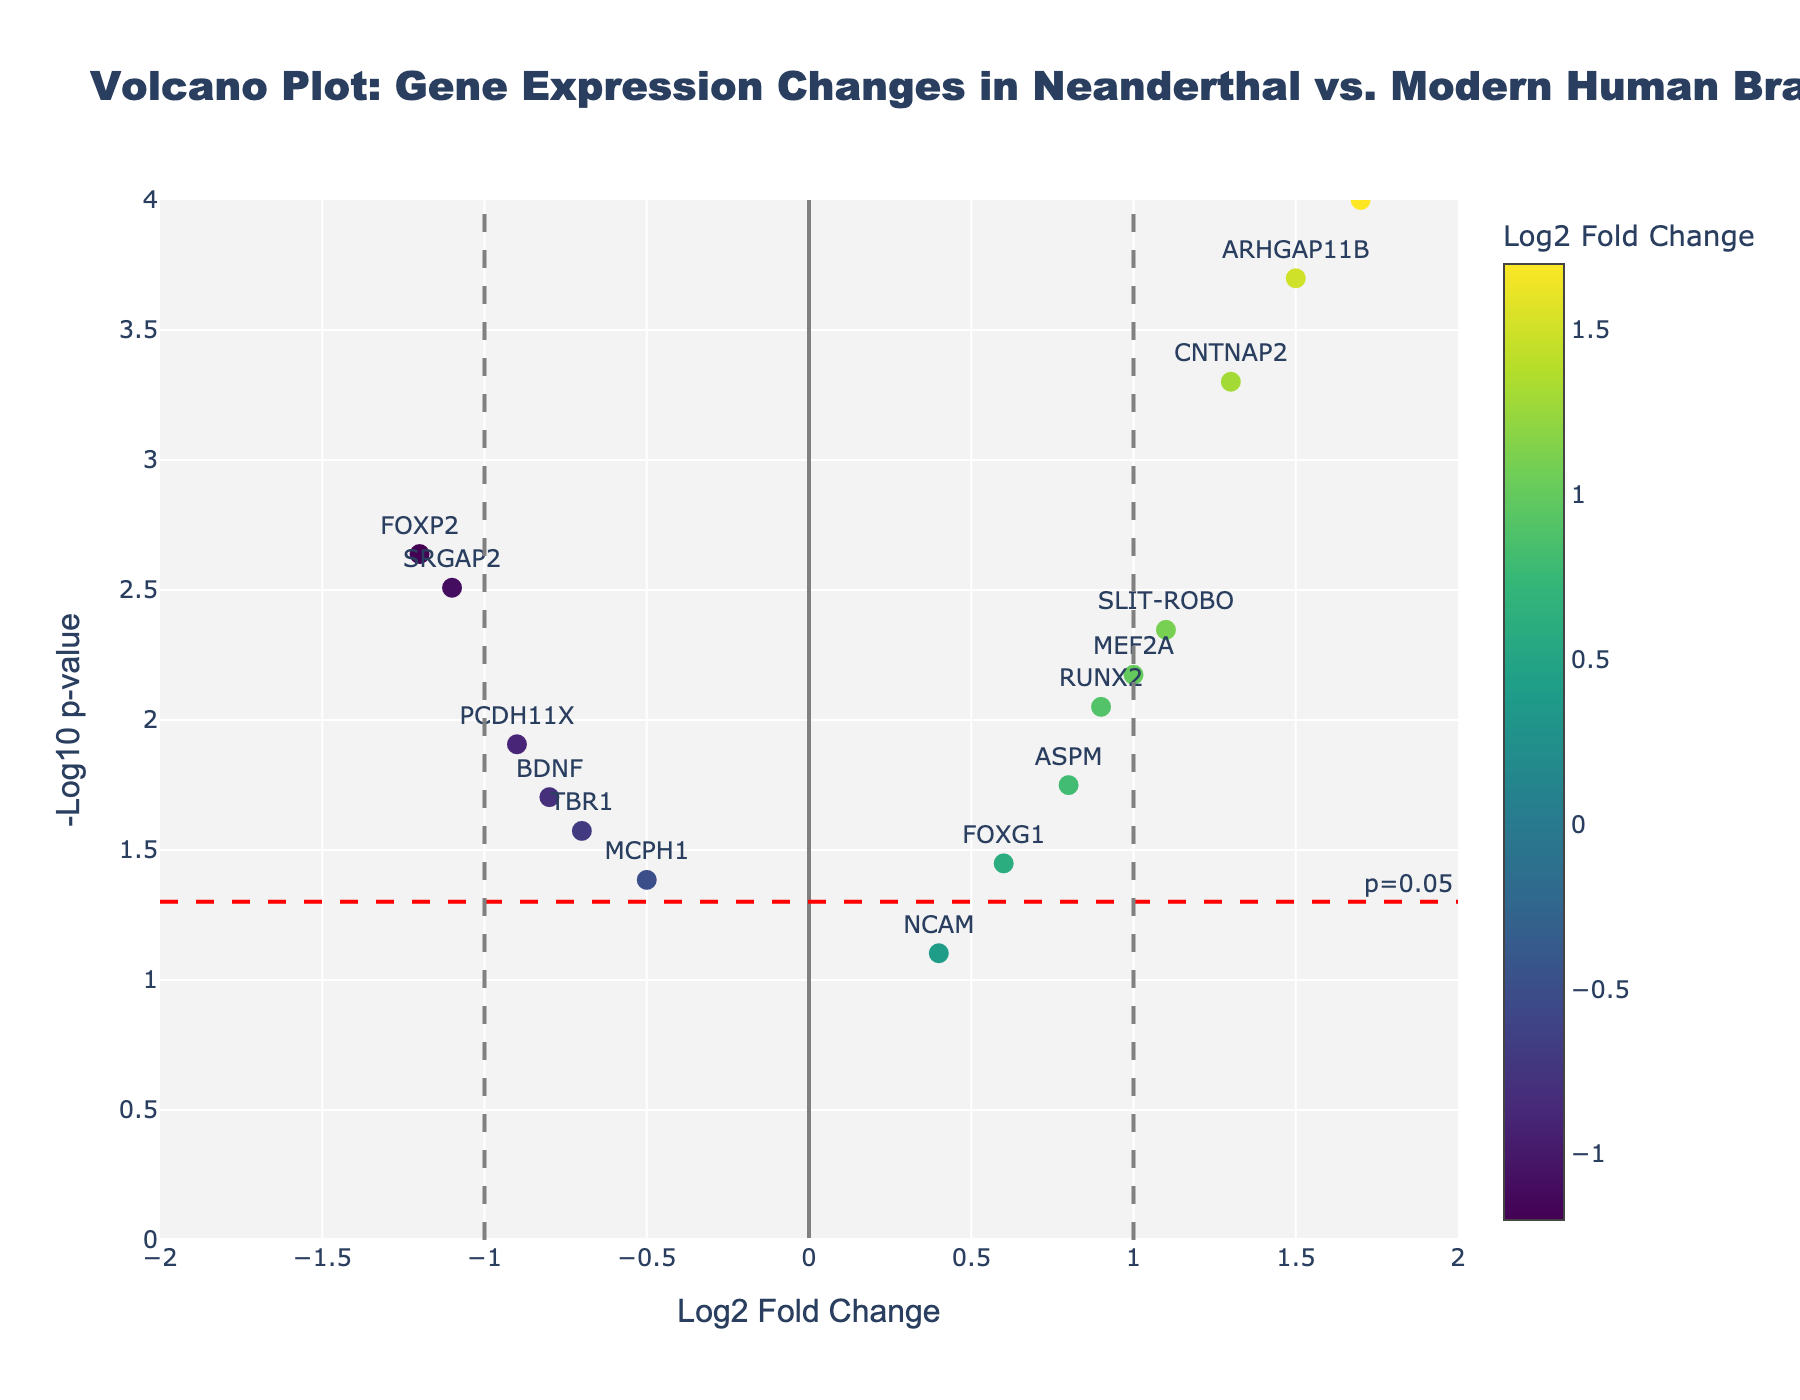How many genes have a p-value less than or equal to 0.05? To determine this, count the data points that lie above the horizontal threshold line (since -log10(p=0.05) is 1.30, genes with higher values indicate significant results).
Answer: 13 Which gene has the highest log2 fold change? Identify the data point furthest to the right on the x-axis.
Answer: NOTCH2NL Which gene has the lowest log2 fold change? Identify the data point furthest to the left on the x-axis.
Answer: FOXP2 What is the range of -log10 p-values in the plot? Locate the highest and lowest points on the y-axis to find the range. The highest is around 4 (NOTCH2NL), and the lowest just above 0 (NCAM).
Answer: Just above 0 to around 4 How many genes show a log2 fold change greater than 1 and a p-value less than 0.05? Count the data points that lie to the right of the x=1 vertical line and above the horizontal threshold line (-log10(p=0.05)).
Answer: 4 (CNTNAP2, ARHGAP11B, NOTCH2NL, SLIT-ROBO) Which gene has the closest log2 fold change to zero but a significant p-value (p < 0.05)? Identify the data point nearest the x=0 line that lies above the horizontal threshold line.
Answer: NCAM Which two genes have opposite log2 fold changes but similar p-values? Compare data points on opposite sides of the x-axis (positive vs. negative fold changes) that have y-axis positions (p-values) that are close to each other.
Answer: FOXP2 and MEF2A How many genes have a negative log2 fold change and a p-value less than 0.05? Count the data points that lie to the left of the x=-1 vertical line and above the horizontal threshold line (-log10(p=0.05)).
Answer: 5 (FOXP2, MCPH1, SRGAP2, TBR1, BDNF) 